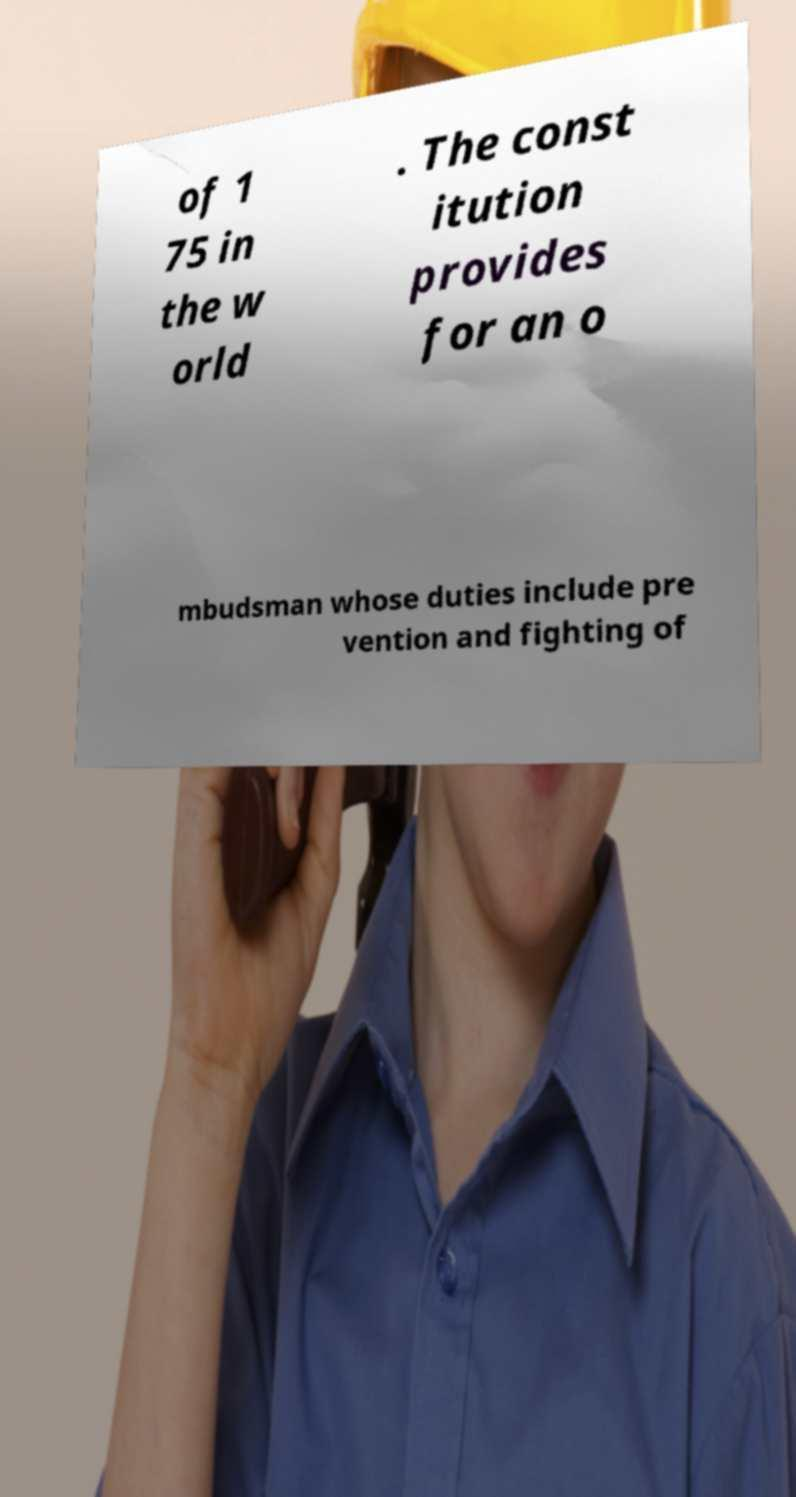There's text embedded in this image that I need extracted. Can you transcribe it verbatim? of 1 75 in the w orld . The const itution provides for an o mbudsman whose duties include pre vention and fighting of 